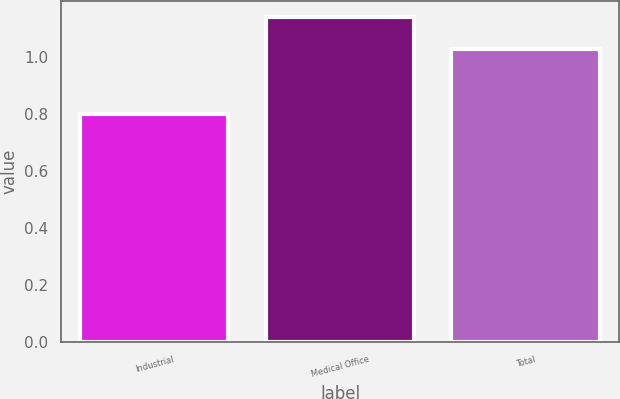Convert chart to OTSL. <chart><loc_0><loc_0><loc_500><loc_500><bar_chart><fcel>Industrial<fcel>Medical Office<fcel>Total<nl><fcel>0.8<fcel>1.14<fcel>1.03<nl></chart> 